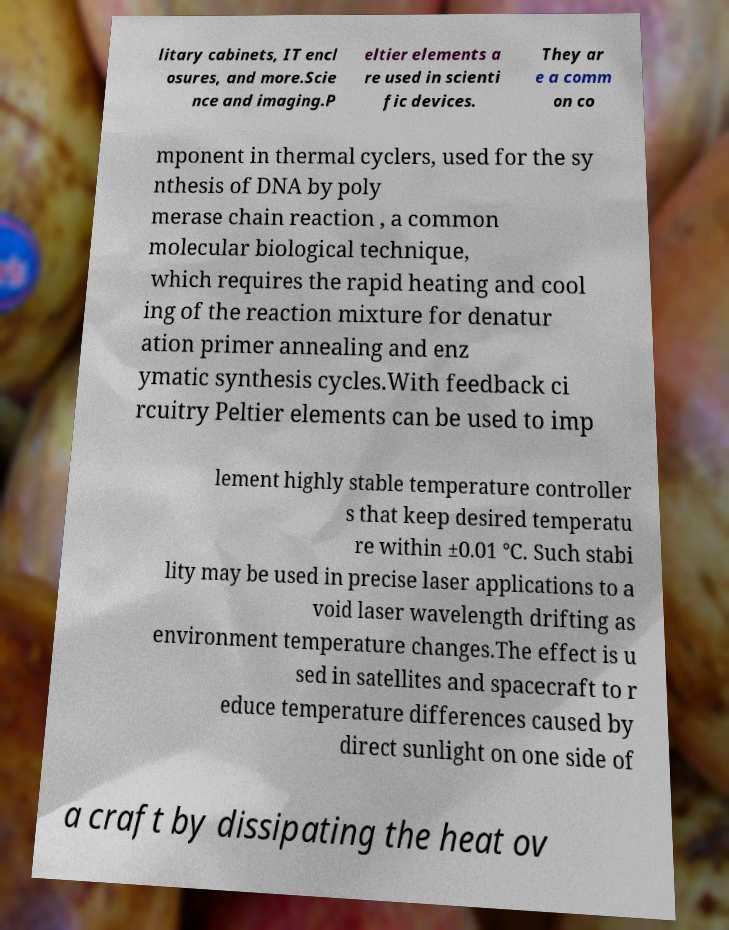Please identify and transcribe the text found in this image. litary cabinets, IT encl osures, and more.Scie nce and imaging.P eltier elements a re used in scienti fic devices. They ar e a comm on co mponent in thermal cyclers, used for the sy nthesis of DNA by poly merase chain reaction , a common molecular biological technique, which requires the rapid heating and cool ing of the reaction mixture for denatur ation primer annealing and enz ymatic synthesis cycles.With feedback ci rcuitry Peltier elements can be used to imp lement highly stable temperature controller s that keep desired temperatu re within ±0.01 °C. Such stabi lity may be used in precise laser applications to a void laser wavelength drifting as environment temperature changes.The effect is u sed in satellites and spacecraft to r educe temperature differences caused by direct sunlight on one side of a craft by dissipating the heat ov 